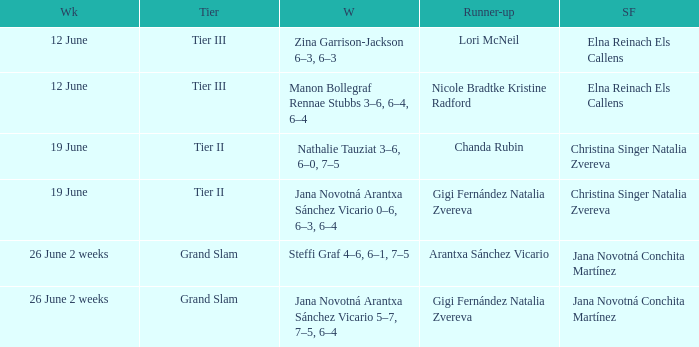When the Tier is listed as tier iii, who is the Winner? Zina Garrison-Jackson 6–3, 6–3, Manon Bollegraf Rennae Stubbs 3–6, 6–4, 6–4. 